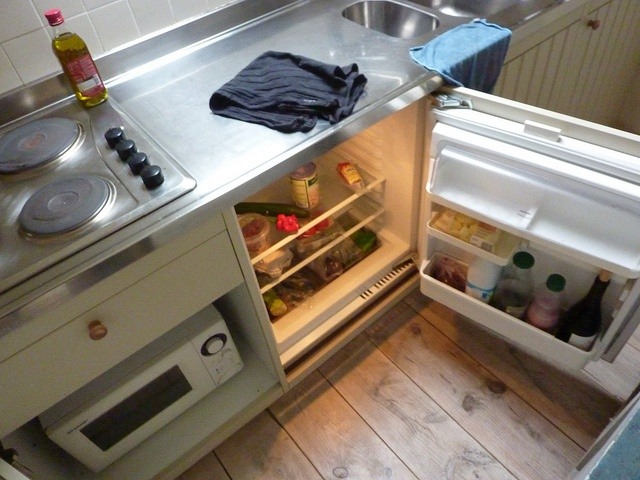Describe the objects in this image and their specific colors. I can see refrigerator in gray, darkgray, lightgray, and tan tones, oven in gray, darkgray, and black tones, microwave in gray and black tones, bottle in gray, maroon, olive, darkgray, and brown tones, and sink in gray, darkgray, and lightgray tones in this image. 